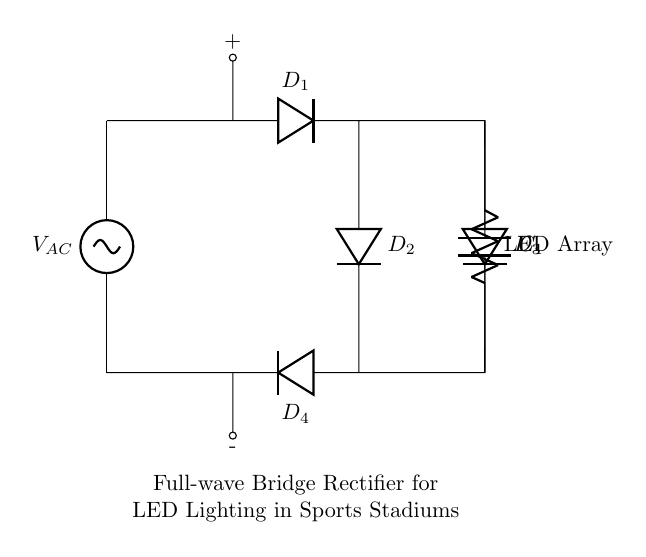What is the type of rectifier used in this circuit? The rectifier used is a full-wave bridge rectifier, characterized by four diodes arranged in a bridge configuration that allows for both halves of the AC waveform to be utilized.
Answer: full-wave bridge rectifier How many diodes are present in the circuit? There are four diodes labeled D1, D2, D3, and D4, which work together in the bridge configuration to convert AC to DC.
Answer: four What is the purpose of capacitor C1 in the circuit? Capacitor C1 is used for smoothing the output voltage from the rectifier, reducing ripple and providing a more stable DC voltage for the LED array.
Answer: smoothing What component is connected to the output of the rectifier? The load connected to the output of the rectifier is an LED array, which uses the DC voltage provided to light up the stadium.
Answer: LED array What type of source is supplying the circuit? The source supplying the circuit is an AC source, indicated by the label V_AC at the beginning of the circuit.
Answer: AC How does the bridge rectifier efficiently convert AC to DC? The bridge rectifier efficiently converts AC to DC by allowing current to flow through the load during both the positive and negative cycles of the input AC voltage, effectively utilizing the full waveform and producing a smoother DC output.
Answer: by utilizing both cycles 